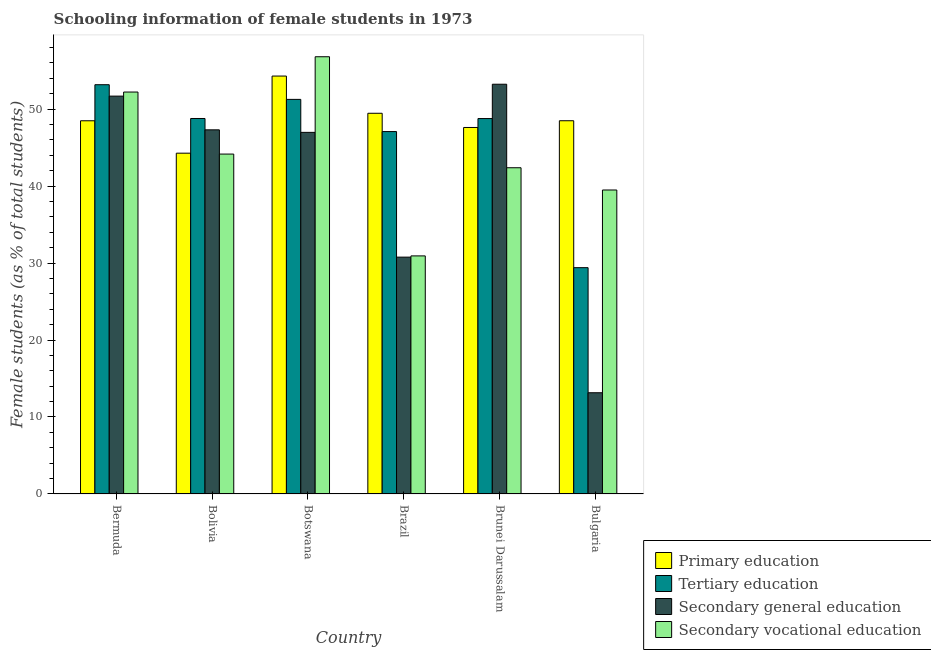How many groups of bars are there?
Make the answer very short. 6. Are the number of bars on each tick of the X-axis equal?
Your answer should be compact. Yes. How many bars are there on the 1st tick from the left?
Offer a terse response. 4. What is the label of the 3rd group of bars from the left?
Make the answer very short. Botswana. In how many cases, is the number of bars for a given country not equal to the number of legend labels?
Give a very brief answer. 0. What is the percentage of female students in secondary education in Brunei Darussalam?
Your answer should be compact. 53.23. Across all countries, what is the maximum percentage of female students in primary education?
Your answer should be very brief. 54.29. Across all countries, what is the minimum percentage of female students in secondary education?
Provide a succinct answer. 13.15. In which country was the percentage of female students in tertiary education maximum?
Offer a very short reply. Bermuda. In which country was the percentage of female students in secondary vocational education minimum?
Give a very brief answer. Brazil. What is the total percentage of female students in secondary vocational education in the graph?
Your response must be concise. 265.99. What is the difference between the percentage of female students in tertiary education in Bermuda and that in Bolivia?
Your answer should be very brief. 4.39. What is the difference between the percentage of female students in primary education in Brazil and the percentage of female students in secondary education in Botswana?
Your answer should be compact. 2.48. What is the average percentage of female students in tertiary education per country?
Your response must be concise. 46.41. What is the difference between the percentage of female students in tertiary education and percentage of female students in secondary vocational education in Brunei Darussalam?
Your response must be concise. 6.39. What is the ratio of the percentage of female students in primary education in Bolivia to that in Brunei Darussalam?
Provide a short and direct response. 0.93. Is the percentage of female students in secondary education in Bolivia less than that in Brunei Darussalam?
Ensure brevity in your answer.  Yes. Is the difference between the percentage of female students in secondary vocational education in Bermuda and Brunei Darussalam greater than the difference between the percentage of female students in tertiary education in Bermuda and Brunei Darussalam?
Your response must be concise. Yes. What is the difference between the highest and the second highest percentage of female students in primary education?
Ensure brevity in your answer.  4.83. What is the difference between the highest and the lowest percentage of female students in tertiary education?
Give a very brief answer. 23.77. Is the sum of the percentage of female students in secondary education in Botswana and Bulgaria greater than the maximum percentage of female students in primary education across all countries?
Your response must be concise. Yes. Is it the case that in every country, the sum of the percentage of female students in primary education and percentage of female students in secondary vocational education is greater than the sum of percentage of female students in tertiary education and percentage of female students in secondary education?
Give a very brief answer. No. What does the 3rd bar from the left in Botswana represents?
Ensure brevity in your answer.  Secondary general education. What does the 2nd bar from the right in Bulgaria represents?
Provide a short and direct response. Secondary general education. How many bars are there?
Your response must be concise. 24. Are all the bars in the graph horizontal?
Your response must be concise. No. How many countries are there in the graph?
Keep it short and to the point. 6. Does the graph contain any zero values?
Ensure brevity in your answer.  No. Where does the legend appear in the graph?
Offer a very short reply. Bottom right. How many legend labels are there?
Give a very brief answer. 4. How are the legend labels stacked?
Your answer should be very brief. Vertical. What is the title of the graph?
Ensure brevity in your answer.  Schooling information of female students in 1973. Does "Forest" appear as one of the legend labels in the graph?
Provide a short and direct response. No. What is the label or title of the X-axis?
Offer a very short reply. Country. What is the label or title of the Y-axis?
Your answer should be compact. Female students (as % of total students). What is the Female students (as % of total students) in Primary education in Bermuda?
Your answer should be compact. 48.49. What is the Female students (as % of total students) in Tertiary education in Bermuda?
Keep it short and to the point. 53.17. What is the Female students (as % of total students) in Secondary general education in Bermuda?
Provide a succinct answer. 51.69. What is the Female students (as % of total students) of Secondary vocational education in Bermuda?
Provide a short and direct response. 52.22. What is the Female students (as % of total students) of Primary education in Bolivia?
Keep it short and to the point. 44.27. What is the Female students (as % of total students) of Tertiary education in Bolivia?
Your answer should be compact. 48.78. What is the Female students (as % of total students) of Secondary general education in Bolivia?
Keep it short and to the point. 47.31. What is the Female students (as % of total students) of Secondary vocational education in Bolivia?
Make the answer very short. 44.16. What is the Female students (as % of total students) of Primary education in Botswana?
Ensure brevity in your answer.  54.29. What is the Female students (as % of total students) of Tertiary education in Botswana?
Offer a very short reply. 51.26. What is the Female students (as % of total students) of Secondary general education in Botswana?
Make the answer very short. 46.98. What is the Female students (as % of total students) in Secondary vocational education in Botswana?
Make the answer very short. 56.8. What is the Female students (as % of total students) in Primary education in Brazil?
Provide a succinct answer. 49.46. What is the Female students (as % of total students) of Tertiary education in Brazil?
Provide a succinct answer. 47.08. What is the Female students (as % of total students) of Secondary general education in Brazil?
Offer a very short reply. 30.77. What is the Female students (as % of total students) in Secondary vocational education in Brazil?
Your answer should be very brief. 30.93. What is the Female students (as % of total students) in Primary education in Brunei Darussalam?
Offer a very short reply. 47.61. What is the Female students (as % of total students) in Tertiary education in Brunei Darussalam?
Ensure brevity in your answer.  48.77. What is the Female students (as % of total students) in Secondary general education in Brunei Darussalam?
Keep it short and to the point. 53.23. What is the Female students (as % of total students) of Secondary vocational education in Brunei Darussalam?
Ensure brevity in your answer.  42.38. What is the Female students (as % of total students) in Primary education in Bulgaria?
Your answer should be very brief. 48.49. What is the Female students (as % of total students) in Tertiary education in Bulgaria?
Give a very brief answer. 29.4. What is the Female students (as % of total students) in Secondary general education in Bulgaria?
Your answer should be very brief. 13.15. What is the Female students (as % of total students) of Secondary vocational education in Bulgaria?
Offer a terse response. 39.49. Across all countries, what is the maximum Female students (as % of total students) of Primary education?
Give a very brief answer. 54.29. Across all countries, what is the maximum Female students (as % of total students) in Tertiary education?
Provide a short and direct response. 53.17. Across all countries, what is the maximum Female students (as % of total students) in Secondary general education?
Offer a terse response. 53.23. Across all countries, what is the maximum Female students (as % of total students) in Secondary vocational education?
Offer a very short reply. 56.8. Across all countries, what is the minimum Female students (as % of total students) in Primary education?
Provide a short and direct response. 44.27. Across all countries, what is the minimum Female students (as % of total students) of Tertiary education?
Give a very brief answer. 29.4. Across all countries, what is the minimum Female students (as % of total students) of Secondary general education?
Provide a succinct answer. 13.15. Across all countries, what is the minimum Female students (as % of total students) of Secondary vocational education?
Your answer should be compact. 30.93. What is the total Female students (as % of total students) in Primary education in the graph?
Your response must be concise. 292.62. What is the total Female students (as % of total students) of Tertiary education in the graph?
Provide a short and direct response. 278.47. What is the total Female students (as % of total students) of Secondary general education in the graph?
Offer a terse response. 243.13. What is the total Female students (as % of total students) of Secondary vocational education in the graph?
Make the answer very short. 265.99. What is the difference between the Female students (as % of total students) in Primary education in Bermuda and that in Bolivia?
Keep it short and to the point. 4.21. What is the difference between the Female students (as % of total students) in Tertiary education in Bermuda and that in Bolivia?
Give a very brief answer. 4.39. What is the difference between the Female students (as % of total students) of Secondary general education in Bermuda and that in Bolivia?
Keep it short and to the point. 4.38. What is the difference between the Female students (as % of total students) in Secondary vocational education in Bermuda and that in Bolivia?
Your answer should be compact. 8.06. What is the difference between the Female students (as % of total students) of Primary education in Bermuda and that in Botswana?
Offer a very short reply. -5.81. What is the difference between the Female students (as % of total students) of Tertiary education in Bermuda and that in Botswana?
Keep it short and to the point. 1.91. What is the difference between the Female students (as % of total students) of Secondary general education in Bermuda and that in Botswana?
Make the answer very short. 4.71. What is the difference between the Female students (as % of total students) in Secondary vocational education in Bermuda and that in Botswana?
Provide a succinct answer. -4.59. What is the difference between the Female students (as % of total students) of Primary education in Bermuda and that in Brazil?
Your answer should be compact. -0.97. What is the difference between the Female students (as % of total students) in Tertiary education in Bermuda and that in Brazil?
Keep it short and to the point. 6.09. What is the difference between the Female students (as % of total students) in Secondary general education in Bermuda and that in Brazil?
Your answer should be very brief. 20.92. What is the difference between the Female students (as % of total students) in Secondary vocational education in Bermuda and that in Brazil?
Ensure brevity in your answer.  21.29. What is the difference between the Female students (as % of total students) in Primary education in Bermuda and that in Brunei Darussalam?
Offer a terse response. 0.87. What is the difference between the Female students (as % of total students) of Tertiary education in Bermuda and that in Brunei Darussalam?
Give a very brief answer. 4.4. What is the difference between the Female students (as % of total students) in Secondary general education in Bermuda and that in Brunei Darussalam?
Your response must be concise. -1.54. What is the difference between the Female students (as % of total students) in Secondary vocational education in Bermuda and that in Brunei Darussalam?
Provide a succinct answer. 9.84. What is the difference between the Female students (as % of total students) of Primary education in Bermuda and that in Bulgaria?
Keep it short and to the point. -0. What is the difference between the Female students (as % of total students) in Tertiary education in Bermuda and that in Bulgaria?
Make the answer very short. 23.77. What is the difference between the Female students (as % of total students) of Secondary general education in Bermuda and that in Bulgaria?
Offer a very short reply. 38.54. What is the difference between the Female students (as % of total students) in Secondary vocational education in Bermuda and that in Bulgaria?
Your answer should be compact. 12.73. What is the difference between the Female students (as % of total students) of Primary education in Bolivia and that in Botswana?
Provide a short and direct response. -10.02. What is the difference between the Female students (as % of total students) of Tertiary education in Bolivia and that in Botswana?
Your answer should be very brief. -2.48. What is the difference between the Female students (as % of total students) of Secondary general education in Bolivia and that in Botswana?
Offer a terse response. 0.33. What is the difference between the Female students (as % of total students) in Secondary vocational education in Bolivia and that in Botswana?
Ensure brevity in your answer.  -12.65. What is the difference between the Female students (as % of total students) in Primary education in Bolivia and that in Brazil?
Provide a short and direct response. -5.19. What is the difference between the Female students (as % of total students) of Tertiary education in Bolivia and that in Brazil?
Provide a short and direct response. 1.7. What is the difference between the Female students (as % of total students) in Secondary general education in Bolivia and that in Brazil?
Keep it short and to the point. 16.54. What is the difference between the Female students (as % of total students) of Secondary vocational education in Bolivia and that in Brazil?
Give a very brief answer. 13.23. What is the difference between the Female students (as % of total students) in Primary education in Bolivia and that in Brunei Darussalam?
Your answer should be compact. -3.34. What is the difference between the Female students (as % of total students) of Tertiary education in Bolivia and that in Brunei Darussalam?
Offer a terse response. 0.01. What is the difference between the Female students (as % of total students) in Secondary general education in Bolivia and that in Brunei Darussalam?
Offer a terse response. -5.92. What is the difference between the Female students (as % of total students) of Secondary vocational education in Bolivia and that in Brunei Darussalam?
Offer a very short reply. 1.78. What is the difference between the Female students (as % of total students) of Primary education in Bolivia and that in Bulgaria?
Offer a terse response. -4.22. What is the difference between the Female students (as % of total students) in Tertiary education in Bolivia and that in Bulgaria?
Your answer should be compact. 19.38. What is the difference between the Female students (as % of total students) in Secondary general education in Bolivia and that in Bulgaria?
Your answer should be very brief. 34.16. What is the difference between the Female students (as % of total students) of Secondary vocational education in Bolivia and that in Bulgaria?
Keep it short and to the point. 4.67. What is the difference between the Female students (as % of total students) in Primary education in Botswana and that in Brazil?
Keep it short and to the point. 4.83. What is the difference between the Female students (as % of total students) of Tertiary education in Botswana and that in Brazil?
Offer a very short reply. 4.18. What is the difference between the Female students (as % of total students) of Secondary general education in Botswana and that in Brazil?
Provide a short and direct response. 16.21. What is the difference between the Female students (as % of total students) in Secondary vocational education in Botswana and that in Brazil?
Offer a very short reply. 25.87. What is the difference between the Female students (as % of total students) of Primary education in Botswana and that in Brunei Darussalam?
Offer a terse response. 6.68. What is the difference between the Female students (as % of total students) of Tertiary education in Botswana and that in Brunei Darussalam?
Your response must be concise. 2.49. What is the difference between the Female students (as % of total students) of Secondary general education in Botswana and that in Brunei Darussalam?
Make the answer very short. -6.25. What is the difference between the Female students (as % of total students) in Secondary vocational education in Botswana and that in Brunei Darussalam?
Keep it short and to the point. 14.42. What is the difference between the Female students (as % of total students) of Primary education in Botswana and that in Bulgaria?
Offer a very short reply. 5.8. What is the difference between the Female students (as % of total students) of Tertiary education in Botswana and that in Bulgaria?
Your answer should be compact. 21.86. What is the difference between the Female students (as % of total students) of Secondary general education in Botswana and that in Bulgaria?
Make the answer very short. 33.83. What is the difference between the Female students (as % of total students) in Secondary vocational education in Botswana and that in Bulgaria?
Your answer should be compact. 17.31. What is the difference between the Female students (as % of total students) in Primary education in Brazil and that in Brunei Darussalam?
Provide a succinct answer. 1.84. What is the difference between the Female students (as % of total students) of Tertiary education in Brazil and that in Brunei Darussalam?
Offer a very short reply. -1.69. What is the difference between the Female students (as % of total students) in Secondary general education in Brazil and that in Brunei Darussalam?
Give a very brief answer. -22.46. What is the difference between the Female students (as % of total students) in Secondary vocational education in Brazil and that in Brunei Darussalam?
Keep it short and to the point. -11.45. What is the difference between the Female students (as % of total students) of Primary education in Brazil and that in Bulgaria?
Offer a terse response. 0.97. What is the difference between the Female students (as % of total students) of Tertiary education in Brazil and that in Bulgaria?
Your answer should be very brief. 17.68. What is the difference between the Female students (as % of total students) of Secondary general education in Brazil and that in Bulgaria?
Offer a very short reply. 17.62. What is the difference between the Female students (as % of total students) in Secondary vocational education in Brazil and that in Bulgaria?
Your response must be concise. -8.56. What is the difference between the Female students (as % of total students) of Primary education in Brunei Darussalam and that in Bulgaria?
Provide a short and direct response. -0.88. What is the difference between the Female students (as % of total students) in Tertiary education in Brunei Darussalam and that in Bulgaria?
Offer a terse response. 19.37. What is the difference between the Female students (as % of total students) of Secondary general education in Brunei Darussalam and that in Bulgaria?
Offer a terse response. 40.08. What is the difference between the Female students (as % of total students) in Secondary vocational education in Brunei Darussalam and that in Bulgaria?
Ensure brevity in your answer.  2.89. What is the difference between the Female students (as % of total students) of Primary education in Bermuda and the Female students (as % of total students) of Tertiary education in Bolivia?
Make the answer very short. -0.3. What is the difference between the Female students (as % of total students) in Primary education in Bermuda and the Female students (as % of total students) in Secondary general education in Bolivia?
Provide a short and direct response. 1.18. What is the difference between the Female students (as % of total students) of Primary education in Bermuda and the Female students (as % of total students) of Secondary vocational education in Bolivia?
Your answer should be very brief. 4.33. What is the difference between the Female students (as % of total students) in Tertiary education in Bermuda and the Female students (as % of total students) in Secondary general education in Bolivia?
Your response must be concise. 5.86. What is the difference between the Female students (as % of total students) in Tertiary education in Bermuda and the Female students (as % of total students) in Secondary vocational education in Bolivia?
Your response must be concise. 9.01. What is the difference between the Female students (as % of total students) of Secondary general education in Bermuda and the Female students (as % of total students) of Secondary vocational education in Bolivia?
Provide a short and direct response. 7.53. What is the difference between the Female students (as % of total students) in Primary education in Bermuda and the Female students (as % of total students) in Tertiary education in Botswana?
Ensure brevity in your answer.  -2.78. What is the difference between the Female students (as % of total students) of Primary education in Bermuda and the Female students (as % of total students) of Secondary general education in Botswana?
Provide a succinct answer. 1.51. What is the difference between the Female students (as % of total students) of Primary education in Bermuda and the Female students (as % of total students) of Secondary vocational education in Botswana?
Keep it short and to the point. -8.32. What is the difference between the Female students (as % of total students) of Tertiary education in Bermuda and the Female students (as % of total students) of Secondary general education in Botswana?
Your answer should be very brief. 6.19. What is the difference between the Female students (as % of total students) of Tertiary education in Bermuda and the Female students (as % of total students) of Secondary vocational education in Botswana?
Make the answer very short. -3.63. What is the difference between the Female students (as % of total students) in Secondary general education in Bermuda and the Female students (as % of total students) in Secondary vocational education in Botswana?
Offer a very short reply. -5.12. What is the difference between the Female students (as % of total students) of Primary education in Bermuda and the Female students (as % of total students) of Tertiary education in Brazil?
Provide a succinct answer. 1.4. What is the difference between the Female students (as % of total students) of Primary education in Bermuda and the Female students (as % of total students) of Secondary general education in Brazil?
Offer a terse response. 17.72. What is the difference between the Female students (as % of total students) in Primary education in Bermuda and the Female students (as % of total students) in Secondary vocational education in Brazil?
Your answer should be very brief. 17.56. What is the difference between the Female students (as % of total students) of Tertiary education in Bermuda and the Female students (as % of total students) of Secondary general education in Brazil?
Your response must be concise. 22.4. What is the difference between the Female students (as % of total students) in Tertiary education in Bermuda and the Female students (as % of total students) in Secondary vocational education in Brazil?
Provide a succinct answer. 22.24. What is the difference between the Female students (as % of total students) of Secondary general education in Bermuda and the Female students (as % of total students) of Secondary vocational education in Brazil?
Your answer should be compact. 20.76. What is the difference between the Female students (as % of total students) in Primary education in Bermuda and the Female students (as % of total students) in Tertiary education in Brunei Darussalam?
Ensure brevity in your answer.  -0.29. What is the difference between the Female students (as % of total students) of Primary education in Bermuda and the Female students (as % of total students) of Secondary general education in Brunei Darussalam?
Your response must be concise. -4.75. What is the difference between the Female students (as % of total students) in Primary education in Bermuda and the Female students (as % of total students) in Secondary vocational education in Brunei Darussalam?
Keep it short and to the point. 6.1. What is the difference between the Female students (as % of total students) of Tertiary education in Bermuda and the Female students (as % of total students) of Secondary general education in Brunei Darussalam?
Give a very brief answer. -0.06. What is the difference between the Female students (as % of total students) of Tertiary education in Bermuda and the Female students (as % of total students) of Secondary vocational education in Brunei Darussalam?
Your answer should be very brief. 10.79. What is the difference between the Female students (as % of total students) in Secondary general education in Bermuda and the Female students (as % of total students) in Secondary vocational education in Brunei Darussalam?
Keep it short and to the point. 9.31. What is the difference between the Female students (as % of total students) in Primary education in Bermuda and the Female students (as % of total students) in Tertiary education in Bulgaria?
Make the answer very short. 19.08. What is the difference between the Female students (as % of total students) in Primary education in Bermuda and the Female students (as % of total students) in Secondary general education in Bulgaria?
Your answer should be very brief. 35.33. What is the difference between the Female students (as % of total students) in Primary education in Bermuda and the Female students (as % of total students) in Secondary vocational education in Bulgaria?
Make the answer very short. 8.99. What is the difference between the Female students (as % of total students) in Tertiary education in Bermuda and the Female students (as % of total students) in Secondary general education in Bulgaria?
Give a very brief answer. 40.02. What is the difference between the Female students (as % of total students) of Tertiary education in Bermuda and the Female students (as % of total students) of Secondary vocational education in Bulgaria?
Make the answer very short. 13.68. What is the difference between the Female students (as % of total students) in Secondary general education in Bermuda and the Female students (as % of total students) in Secondary vocational education in Bulgaria?
Your answer should be compact. 12.2. What is the difference between the Female students (as % of total students) of Primary education in Bolivia and the Female students (as % of total students) of Tertiary education in Botswana?
Ensure brevity in your answer.  -6.99. What is the difference between the Female students (as % of total students) in Primary education in Bolivia and the Female students (as % of total students) in Secondary general education in Botswana?
Provide a short and direct response. -2.7. What is the difference between the Female students (as % of total students) in Primary education in Bolivia and the Female students (as % of total students) in Secondary vocational education in Botswana?
Ensure brevity in your answer.  -12.53. What is the difference between the Female students (as % of total students) of Tertiary education in Bolivia and the Female students (as % of total students) of Secondary general education in Botswana?
Your answer should be very brief. 1.8. What is the difference between the Female students (as % of total students) in Tertiary education in Bolivia and the Female students (as % of total students) in Secondary vocational education in Botswana?
Ensure brevity in your answer.  -8.02. What is the difference between the Female students (as % of total students) in Secondary general education in Bolivia and the Female students (as % of total students) in Secondary vocational education in Botswana?
Keep it short and to the point. -9.5. What is the difference between the Female students (as % of total students) in Primary education in Bolivia and the Female students (as % of total students) in Tertiary education in Brazil?
Keep it short and to the point. -2.81. What is the difference between the Female students (as % of total students) in Primary education in Bolivia and the Female students (as % of total students) in Secondary general education in Brazil?
Your answer should be very brief. 13.51. What is the difference between the Female students (as % of total students) of Primary education in Bolivia and the Female students (as % of total students) of Secondary vocational education in Brazil?
Your answer should be very brief. 13.34. What is the difference between the Female students (as % of total students) in Tertiary education in Bolivia and the Female students (as % of total students) in Secondary general education in Brazil?
Provide a short and direct response. 18.01. What is the difference between the Female students (as % of total students) of Tertiary education in Bolivia and the Female students (as % of total students) of Secondary vocational education in Brazil?
Give a very brief answer. 17.85. What is the difference between the Female students (as % of total students) of Secondary general education in Bolivia and the Female students (as % of total students) of Secondary vocational education in Brazil?
Provide a succinct answer. 16.38. What is the difference between the Female students (as % of total students) in Primary education in Bolivia and the Female students (as % of total students) in Tertiary education in Brunei Darussalam?
Ensure brevity in your answer.  -4.5. What is the difference between the Female students (as % of total students) in Primary education in Bolivia and the Female students (as % of total students) in Secondary general education in Brunei Darussalam?
Provide a succinct answer. -8.96. What is the difference between the Female students (as % of total students) in Primary education in Bolivia and the Female students (as % of total students) in Secondary vocational education in Brunei Darussalam?
Offer a terse response. 1.89. What is the difference between the Female students (as % of total students) of Tertiary education in Bolivia and the Female students (as % of total students) of Secondary general education in Brunei Darussalam?
Offer a very short reply. -4.45. What is the difference between the Female students (as % of total students) in Tertiary education in Bolivia and the Female students (as % of total students) in Secondary vocational education in Brunei Darussalam?
Ensure brevity in your answer.  6.4. What is the difference between the Female students (as % of total students) in Secondary general education in Bolivia and the Female students (as % of total students) in Secondary vocational education in Brunei Darussalam?
Keep it short and to the point. 4.93. What is the difference between the Female students (as % of total students) of Primary education in Bolivia and the Female students (as % of total students) of Tertiary education in Bulgaria?
Make the answer very short. 14.87. What is the difference between the Female students (as % of total students) in Primary education in Bolivia and the Female students (as % of total students) in Secondary general education in Bulgaria?
Make the answer very short. 31.12. What is the difference between the Female students (as % of total students) in Primary education in Bolivia and the Female students (as % of total students) in Secondary vocational education in Bulgaria?
Provide a short and direct response. 4.78. What is the difference between the Female students (as % of total students) in Tertiary education in Bolivia and the Female students (as % of total students) in Secondary general education in Bulgaria?
Ensure brevity in your answer.  35.63. What is the difference between the Female students (as % of total students) in Tertiary education in Bolivia and the Female students (as % of total students) in Secondary vocational education in Bulgaria?
Your response must be concise. 9.29. What is the difference between the Female students (as % of total students) in Secondary general education in Bolivia and the Female students (as % of total students) in Secondary vocational education in Bulgaria?
Ensure brevity in your answer.  7.82. What is the difference between the Female students (as % of total students) in Primary education in Botswana and the Female students (as % of total students) in Tertiary education in Brazil?
Provide a short and direct response. 7.21. What is the difference between the Female students (as % of total students) of Primary education in Botswana and the Female students (as % of total students) of Secondary general education in Brazil?
Provide a succinct answer. 23.53. What is the difference between the Female students (as % of total students) of Primary education in Botswana and the Female students (as % of total students) of Secondary vocational education in Brazil?
Offer a very short reply. 23.36. What is the difference between the Female students (as % of total students) of Tertiary education in Botswana and the Female students (as % of total students) of Secondary general education in Brazil?
Make the answer very short. 20.5. What is the difference between the Female students (as % of total students) in Tertiary education in Botswana and the Female students (as % of total students) in Secondary vocational education in Brazil?
Ensure brevity in your answer.  20.33. What is the difference between the Female students (as % of total students) in Secondary general education in Botswana and the Female students (as % of total students) in Secondary vocational education in Brazil?
Make the answer very short. 16.05. What is the difference between the Female students (as % of total students) of Primary education in Botswana and the Female students (as % of total students) of Tertiary education in Brunei Darussalam?
Keep it short and to the point. 5.52. What is the difference between the Female students (as % of total students) in Primary education in Botswana and the Female students (as % of total students) in Secondary general education in Brunei Darussalam?
Keep it short and to the point. 1.06. What is the difference between the Female students (as % of total students) in Primary education in Botswana and the Female students (as % of total students) in Secondary vocational education in Brunei Darussalam?
Ensure brevity in your answer.  11.91. What is the difference between the Female students (as % of total students) of Tertiary education in Botswana and the Female students (as % of total students) of Secondary general education in Brunei Darussalam?
Give a very brief answer. -1.97. What is the difference between the Female students (as % of total students) of Tertiary education in Botswana and the Female students (as % of total students) of Secondary vocational education in Brunei Darussalam?
Provide a short and direct response. 8.88. What is the difference between the Female students (as % of total students) of Secondary general education in Botswana and the Female students (as % of total students) of Secondary vocational education in Brunei Darussalam?
Offer a terse response. 4.6. What is the difference between the Female students (as % of total students) in Primary education in Botswana and the Female students (as % of total students) in Tertiary education in Bulgaria?
Your answer should be very brief. 24.89. What is the difference between the Female students (as % of total students) in Primary education in Botswana and the Female students (as % of total students) in Secondary general education in Bulgaria?
Ensure brevity in your answer.  41.14. What is the difference between the Female students (as % of total students) of Primary education in Botswana and the Female students (as % of total students) of Secondary vocational education in Bulgaria?
Keep it short and to the point. 14.8. What is the difference between the Female students (as % of total students) in Tertiary education in Botswana and the Female students (as % of total students) in Secondary general education in Bulgaria?
Provide a short and direct response. 38.11. What is the difference between the Female students (as % of total students) in Tertiary education in Botswana and the Female students (as % of total students) in Secondary vocational education in Bulgaria?
Ensure brevity in your answer.  11.77. What is the difference between the Female students (as % of total students) in Secondary general education in Botswana and the Female students (as % of total students) in Secondary vocational education in Bulgaria?
Give a very brief answer. 7.49. What is the difference between the Female students (as % of total students) in Primary education in Brazil and the Female students (as % of total students) in Tertiary education in Brunei Darussalam?
Your answer should be compact. 0.69. What is the difference between the Female students (as % of total students) in Primary education in Brazil and the Female students (as % of total students) in Secondary general education in Brunei Darussalam?
Ensure brevity in your answer.  -3.77. What is the difference between the Female students (as % of total students) of Primary education in Brazil and the Female students (as % of total students) of Secondary vocational education in Brunei Darussalam?
Your answer should be compact. 7.08. What is the difference between the Female students (as % of total students) of Tertiary education in Brazil and the Female students (as % of total students) of Secondary general education in Brunei Darussalam?
Keep it short and to the point. -6.15. What is the difference between the Female students (as % of total students) of Tertiary education in Brazil and the Female students (as % of total students) of Secondary vocational education in Brunei Darussalam?
Give a very brief answer. 4.7. What is the difference between the Female students (as % of total students) of Secondary general education in Brazil and the Female students (as % of total students) of Secondary vocational education in Brunei Darussalam?
Your answer should be compact. -11.61. What is the difference between the Female students (as % of total students) of Primary education in Brazil and the Female students (as % of total students) of Tertiary education in Bulgaria?
Provide a short and direct response. 20.06. What is the difference between the Female students (as % of total students) of Primary education in Brazil and the Female students (as % of total students) of Secondary general education in Bulgaria?
Your response must be concise. 36.31. What is the difference between the Female students (as % of total students) in Primary education in Brazil and the Female students (as % of total students) in Secondary vocational education in Bulgaria?
Ensure brevity in your answer.  9.97. What is the difference between the Female students (as % of total students) in Tertiary education in Brazil and the Female students (as % of total students) in Secondary general education in Bulgaria?
Your answer should be compact. 33.93. What is the difference between the Female students (as % of total students) of Tertiary education in Brazil and the Female students (as % of total students) of Secondary vocational education in Bulgaria?
Your response must be concise. 7.59. What is the difference between the Female students (as % of total students) in Secondary general education in Brazil and the Female students (as % of total students) in Secondary vocational education in Bulgaria?
Your answer should be compact. -8.72. What is the difference between the Female students (as % of total students) of Primary education in Brunei Darussalam and the Female students (as % of total students) of Tertiary education in Bulgaria?
Your answer should be compact. 18.21. What is the difference between the Female students (as % of total students) of Primary education in Brunei Darussalam and the Female students (as % of total students) of Secondary general education in Bulgaria?
Provide a succinct answer. 34.46. What is the difference between the Female students (as % of total students) in Primary education in Brunei Darussalam and the Female students (as % of total students) in Secondary vocational education in Bulgaria?
Offer a terse response. 8.12. What is the difference between the Female students (as % of total students) of Tertiary education in Brunei Darussalam and the Female students (as % of total students) of Secondary general education in Bulgaria?
Your answer should be very brief. 35.62. What is the difference between the Female students (as % of total students) in Tertiary education in Brunei Darussalam and the Female students (as % of total students) in Secondary vocational education in Bulgaria?
Provide a short and direct response. 9.28. What is the difference between the Female students (as % of total students) in Secondary general education in Brunei Darussalam and the Female students (as % of total students) in Secondary vocational education in Bulgaria?
Provide a short and direct response. 13.74. What is the average Female students (as % of total students) in Primary education per country?
Provide a succinct answer. 48.77. What is the average Female students (as % of total students) of Tertiary education per country?
Your answer should be very brief. 46.41. What is the average Female students (as % of total students) of Secondary general education per country?
Make the answer very short. 40.52. What is the average Female students (as % of total students) in Secondary vocational education per country?
Your answer should be compact. 44.33. What is the difference between the Female students (as % of total students) of Primary education and Female students (as % of total students) of Tertiary education in Bermuda?
Ensure brevity in your answer.  -4.68. What is the difference between the Female students (as % of total students) in Primary education and Female students (as % of total students) in Secondary general education in Bermuda?
Offer a terse response. -3.2. What is the difference between the Female students (as % of total students) of Primary education and Female students (as % of total students) of Secondary vocational education in Bermuda?
Offer a terse response. -3.73. What is the difference between the Female students (as % of total students) in Tertiary education and Female students (as % of total students) in Secondary general education in Bermuda?
Provide a succinct answer. 1.48. What is the difference between the Female students (as % of total students) of Tertiary education and Female students (as % of total students) of Secondary vocational education in Bermuda?
Your response must be concise. 0.95. What is the difference between the Female students (as % of total students) of Secondary general education and Female students (as % of total students) of Secondary vocational education in Bermuda?
Your response must be concise. -0.53. What is the difference between the Female students (as % of total students) of Primary education and Female students (as % of total students) of Tertiary education in Bolivia?
Provide a short and direct response. -4.51. What is the difference between the Female students (as % of total students) of Primary education and Female students (as % of total students) of Secondary general education in Bolivia?
Offer a terse response. -3.03. What is the difference between the Female students (as % of total students) in Primary education and Female students (as % of total students) in Secondary vocational education in Bolivia?
Give a very brief answer. 0.12. What is the difference between the Female students (as % of total students) of Tertiary education and Female students (as % of total students) of Secondary general education in Bolivia?
Your answer should be compact. 1.47. What is the difference between the Female students (as % of total students) in Tertiary education and Female students (as % of total students) in Secondary vocational education in Bolivia?
Offer a terse response. 4.62. What is the difference between the Female students (as % of total students) in Secondary general education and Female students (as % of total students) in Secondary vocational education in Bolivia?
Your response must be concise. 3.15. What is the difference between the Female students (as % of total students) in Primary education and Female students (as % of total students) in Tertiary education in Botswana?
Offer a terse response. 3.03. What is the difference between the Female students (as % of total students) in Primary education and Female students (as % of total students) in Secondary general education in Botswana?
Provide a succinct answer. 7.32. What is the difference between the Female students (as % of total students) of Primary education and Female students (as % of total students) of Secondary vocational education in Botswana?
Keep it short and to the point. -2.51. What is the difference between the Female students (as % of total students) of Tertiary education and Female students (as % of total students) of Secondary general education in Botswana?
Make the answer very short. 4.29. What is the difference between the Female students (as % of total students) in Tertiary education and Female students (as % of total students) in Secondary vocational education in Botswana?
Provide a succinct answer. -5.54. What is the difference between the Female students (as % of total students) of Secondary general education and Female students (as % of total students) of Secondary vocational education in Botswana?
Provide a short and direct response. -9.83. What is the difference between the Female students (as % of total students) of Primary education and Female students (as % of total students) of Tertiary education in Brazil?
Provide a succinct answer. 2.38. What is the difference between the Female students (as % of total students) in Primary education and Female students (as % of total students) in Secondary general education in Brazil?
Your answer should be compact. 18.69. What is the difference between the Female students (as % of total students) in Primary education and Female students (as % of total students) in Secondary vocational education in Brazil?
Your response must be concise. 18.53. What is the difference between the Female students (as % of total students) in Tertiary education and Female students (as % of total students) in Secondary general education in Brazil?
Ensure brevity in your answer.  16.31. What is the difference between the Female students (as % of total students) of Tertiary education and Female students (as % of total students) of Secondary vocational education in Brazil?
Offer a very short reply. 16.15. What is the difference between the Female students (as % of total students) of Secondary general education and Female students (as % of total students) of Secondary vocational education in Brazil?
Offer a very short reply. -0.16. What is the difference between the Female students (as % of total students) of Primary education and Female students (as % of total students) of Tertiary education in Brunei Darussalam?
Your answer should be very brief. -1.16. What is the difference between the Female students (as % of total students) of Primary education and Female students (as % of total students) of Secondary general education in Brunei Darussalam?
Your answer should be compact. -5.62. What is the difference between the Female students (as % of total students) of Primary education and Female students (as % of total students) of Secondary vocational education in Brunei Darussalam?
Your answer should be very brief. 5.23. What is the difference between the Female students (as % of total students) of Tertiary education and Female students (as % of total students) of Secondary general education in Brunei Darussalam?
Ensure brevity in your answer.  -4.46. What is the difference between the Female students (as % of total students) in Tertiary education and Female students (as % of total students) in Secondary vocational education in Brunei Darussalam?
Offer a terse response. 6.39. What is the difference between the Female students (as % of total students) in Secondary general education and Female students (as % of total students) in Secondary vocational education in Brunei Darussalam?
Offer a very short reply. 10.85. What is the difference between the Female students (as % of total students) in Primary education and Female students (as % of total students) in Tertiary education in Bulgaria?
Your answer should be compact. 19.09. What is the difference between the Female students (as % of total students) of Primary education and Female students (as % of total students) of Secondary general education in Bulgaria?
Provide a short and direct response. 35.34. What is the difference between the Female students (as % of total students) in Primary education and Female students (as % of total students) in Secondary vocational education in Bulgaria?
Make the answer very short. 9. What is the difference between the Female students (as % of total students) of Tertiary education and Female students (as % of total students) of Secondary general education in Bulgaria?
Ensure brevity in your answer.  16.25. What is the difference between the Female students (as % of total students) of Tertiary education and Female students (as % of total students) of Secondary vocational education in Bulgaria?
Provide a succinct answer. -10.09. What is the difference between the Female students (as % of total students) of Secondary general education and Female students (as % of total students) of Secondary vocational education in Bulgaria?
Offer a terse response. -26.34. What is the ratio of the Female students (as % of total students) of Primary education in Bermuda to that in Bolivia?
Ensure brevity in your answer.  1.1. What is the ratio of the Female students (as % of total students) in Tertiary education in Bermuda to that in Bolivia?
Ensure brevity in your answer.  1.09. What is the ratio of the Female students (as % of total students) in Secondary general education in Bermuda to that in Bolivia?
Provide a short and direct response. 1.09. What is the ratio of the Female students (as % of total students) of Secondary vocational education in Bermuda to that in Bolivia?
Offer a terse response. 1.18. What is the ratio of the Female students (as % of total students) of Primary education in Bermuda to that in Botswana?
Your answer should be very brief. 0.89. What is the ratio of the Female students (as % of total students) in Tertiary education in Bermuda to that in Botswana?
Ensure brevity in your answer.  1.04. What is the ratio of the Female students (as % of total students) in Secondary general education in Bermuda to that in Botswana?
Give a very brief answer. 1.1. What is the ratio of the Female students (as % of total students) of Secondary vocational education in Bermuda to that in Botswana?
Make the answer very short. 0.92. What is the ratio of the Female students (as % of total students) of Primary education in Bermuda to that in Brazil?
Make the answer very short. 0.98. What is the ratio of the Female students (as % of total students) in Tertiary education in Bermuda to that in Brazil?
Offer a terse response. 1.13. What is the ratio of the Female students (as % of total students) in Secondary general education in Bermuda to that in Brazil?
Make the answer very short. 1.68. What is the ratio of the Female students (as % of total students) in Secondary vocational education in Bermuda to that in Brazil?
Your response must be concise. 1.69. What is the ratio of the Female students (as % of total students) in Primary education in Bermuda to that in Brunei Darussalam?
Your answer should be very brief. 1.02. What is the ratio of the Female students (as % of total students) in Tertiary education in Bermuda to that in Brunei Darussalam?
Offer a terse response. 1.09. What is the ratio of the Female students (as % of total students) of Secondary general education in Bermuda to that in Brunei Darussalam?
Keep it short and to the point. 0.97. What is the ratio of the Female students (as % of total students) of Secondary vocational education in Bermuda to that in Brunei Darussalam?
Ensure brevity in your answer.  1.23. What is the ratio of the Female students (as % of total students) in Primary education in Bermuda to that in Bulgaria?
Ensure brevity in your answer.  1. What is the ratio of the Female students (as % of total students) of Tertiary education in Bermuda to that in Bulgaria?
Give a very brief answer. 1.81. What is the ratio of the Female students (as % of total students) of Secondary general education in Bermuda to that in Bulgaria?
Give a very brief answer. 3.93. What is the ratio of the Female students (as % of total students) of Secondary vocational education in Bermuda to that in Bulgaria?
Offer a terse response. 1.32. What is the ratio of the Female students (as % of total students) in Primary education in Bolivia to that in Botswana?
Offer a terse response. 0.82. What is the ratio of the Female students (as % of total students) of Tertiary education in Bolivia to that in Botswana?
Make the answer very short. 0.95. What is the ratio of the Female students (as % of total students) in Secondary general education in Bolivia to that in Botswana?
Provide a short and direct response. 1.01. What is the ratio of the Female students (as % of total students) of Secondary vocational education in Bolivia to that in Botswana?
Ensure brevity in your answer.  0.78. What is the ratio of the Female students (as % of total students) in Primary education in Bolivia to that in Brazil?
Provide a short and direct response. 0.9. What is the ratio of the Female students (as % of total students) in Tertiary education in Bolivia to that in Brazil?
Your answer should be compact. 1.04. What is the ratio of the Female students (as % of total students) in Secondary general education in Bolivia to that in Brazil?
Your answer should be compact. 1.54. What is the ratio of the Female students (as % of total students) in Secondary vocational education in Bolivia to that in Brazil?
Give a very brief answer. 1.43. What is the ratio of the Female students (as % of total students) of Primary education in Bolivia to that in Brunei Darussalam?
Your response must be concise. 0.93. What is the ratio of the Female students (as % of total students) in Secondary general education in Bolivia to that in Brunei Darussalam?
Your response must be concise. 0.89. What is the ratio of the Female students (as % of total students) in Secondary vocational education in Bolivia to that in Brunei Darussalam?
Make the answer very short. 1.04. What is the ratio of the Female students (as % of total students) of Primary education in Bolivia to that in Bulgaria?
Your answer should be very brief. 0.91. What is the ratio of the Female students (as % of total students) in Tertiary education in Bolivia to that in Bulgaria?
Make the answer very short. 1.66. What is the ratio of the Female students (as % of total students) in Secondary general education in Bolivia to that in Bulgaria?
Make the answer very short. 3.6. What is the ratio of the Female students (as % of total students) of Secondary vocational education in Bolivia to that in Bulgaria?
Offer a terse response. 1.12. What is the ratio of the Female students (as % of total students) of Primary education in Botswana to that in Brazil?
Provide a succinct answer. 1.1. What is the ratio of the Female students (as % of total students) of Tertiary education in Botswana to that in Brazil?
Provide a succinct answer. 1.09. What is the ratio of the Female students (as % of total students) in Secondary general education in Botswana to that in Brazil?
Offer a terse response. 1.53. What is the ratio of the Female students (as % of total students) in Secondary vocational education in Botswana to that in Brazil?
Ensure brevity in your answer.  1.84. What is the ratio of the Female students (as % of total students) of Primary education in Botswana to that in Brunei Darussalam?
Offer a terse response. 1.14. What is the ratio of the Female students (as % of total students) in Tertiary education in Botswana to that in Brunei Darussalam?
Provide a succinct answer. 1.05. What is the ratio of the Female students (as % of total students) of Secondary general education in Botswana to that in Brunei Darussalam?
Keep it short and to the point. 0.88. What is the ratio of the Female students (as % of total students) of Secondary vocational education in Botswana to that in Brunei Darussalam?
Make the answer very short. 1.34. What is the ratio of the Female students (as % of total students) of Primary education in Botswana to that in Bulgaria?
Offer a very short reply. 1.12. What is the ratio of the Female students (as % of total students) in Tertiary education in Botswana to that in Bulgaria?
Ensure brevity in your answer.  1.74. What is the ratio of the Female students (as % of total students) in Secondary general education in Botswana to that in Bulgaria?
Your answer should be compact. 3.57. What is the ratio of the Female students (as % of total students) of Secondary vocational education in Botswana to that in Bulgaria?
Your answer should be compact. 1.44. What is the ratio of the Female students (as % of total students) of Primary education in Brazil to that in Brunei Darussalam?
Your answer should be very brief. 1.04. What is the ratio of the Female students (as % of total students) in Tertiary education in Brazil to that in Brunei Darussalam?
Give a very brief answer. 0.97. What is the ratio of the Female students (as % of total students) of Secondary general education in Brazil to that in Brunei Darussalam?
Your response must be concise. 0.58. What is the ratio of the Female students (as % of total students) of Secondary vocational education in Brazil to that in Brunei Darussalam?
Your answer should be very brief. 0.73. What is the ratio of the Female students (as % of total students) of Primary education in Brazil to that in Bulgaria?
Give a very brief answer. 1.02. What is the ratio of the Female students (as % of total students) in Tertiary education in Brazil to that in Bulgaria?
Offer a terse response. 1.6. What is the ratio of the Female students (as % of total students) of Secondary general education in Brazil to that in Bulgaria?
Offer a very short reply. 2.34. What is the ratio of the Female students (as % of total students) in Secondary vocational education in Brazil to that in Bulgaria?
Your answer should be very brief. 0.78. What is the ratio of the Female students (as % of total students) of Primary education in Brunei Darussalam to that in Bulgaria?
Your answer should be very brief. 0.98. What is the ratio of the Female students (as % of total students) in Tertiary education in Brunei Darussalam to that in Bulgaria?
Offer a terse response. 1.66. What is the ratio of the Female students (as % of total students) in Secondary general education in Brunei Darussalam to that in Bulgaria?
Offer a very short reply. 4.05. What is the ratio of the Female students (as % of total students) in Secondary vocational education in Brunei Darussalam to that in Bulgaria?
Offer a very short reply. 1.07. What is the difference between the highest and the second highest Female students (as % of total students) in Primary education?
Give a very brief answer. 4.83. What is the difference between the highest and the second highest Female students (as % of total students) of Tertiary education?
Offer a terse response. 1.91. What is the difference between the highest and the second highest Female students (as % of total students) of Secondary general education?
Ensure brevity in your answer.  1.54. What is the difference between the highest and the second highest Female students (as % of total students) of Secondary vocational education?
Give a very brief answer. 4.59. What is the difference between the highest and the lowest Female students (as % of total students) of Primary education?
Provide a short and direct response. 10.02. What is the difference between the highest and the lowest Female students (as % of total students) of Tertiary education?
Your response must be concise. 23.77. What is the difference between the highest and the lowest Female students (as % of total students) in Secondary general education?
Give a very brief answer. 40.08. What is the difference between the highest and the lowest Female students (as % of total students) in Secondary vocational education?
Offer a very short reply. 25.87. 